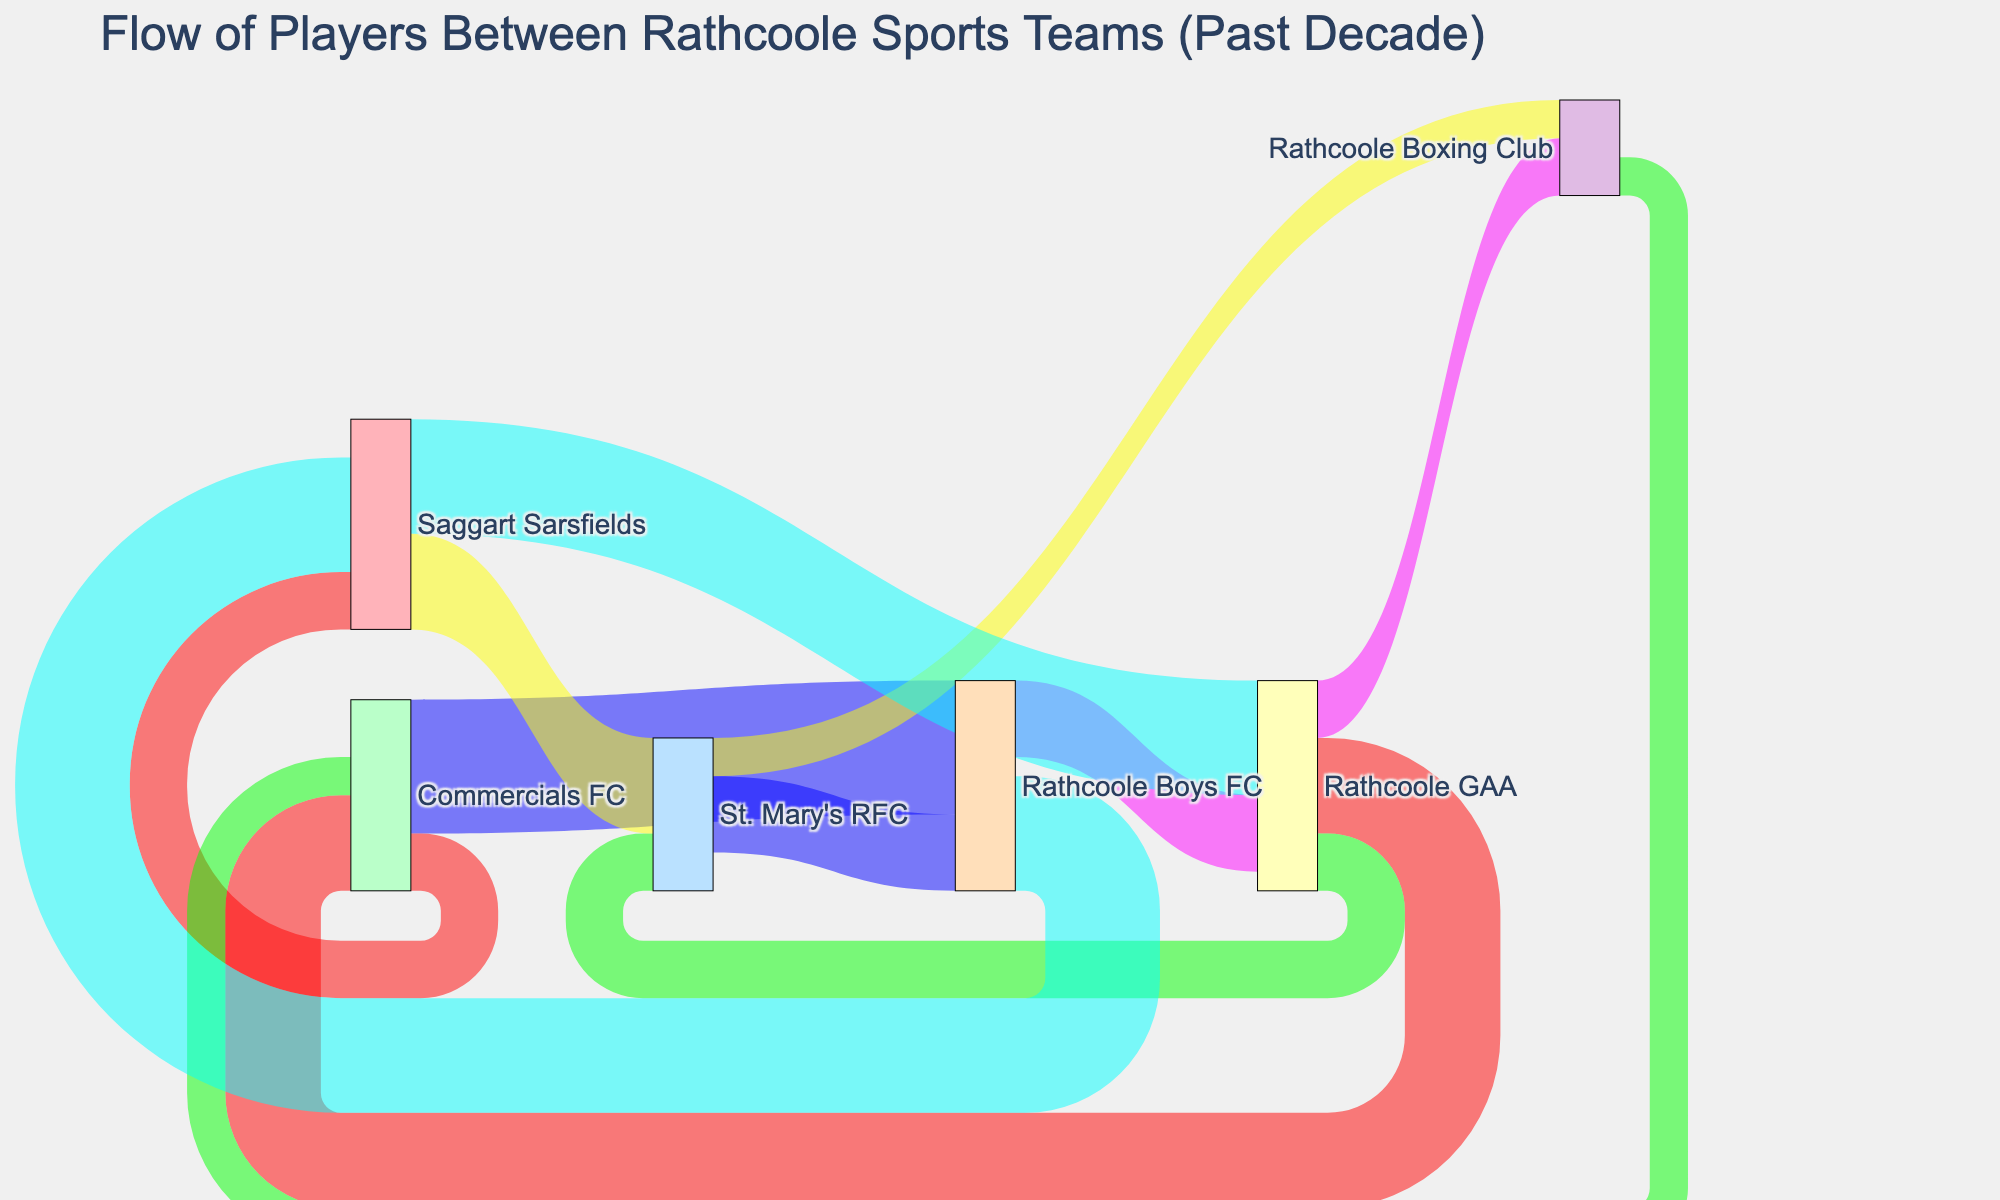How many players moved from Rathcoole GAA to other teams? Look at the links originating from Rathcoole GAA. Sum the values of the links going to Commercials FC, St. Mary's RFC, and Rathcoole Boxing Club: 5 (to Commercials FC) + 3 (to St. Mary's RFC) + 3 (to Rathcoole Boxing Club) = 11
Answer: 11 Which team received the most players from Rathcoole Boys FC? Identify the links originating from Rathcoole Boys FC and find the one with the highest value. The link values are 4 (to Rathcoole GAA) and 6 (to Saggart Sarsfields). The highest is 6 to Saggart Sarsfields
Answer: Saggart Sarsfields What is the total number of players that moved to Rathcoole GAA? Locate the links that end at Rathcoole GAA. Sum the values of these links: 4 from Rathcoole Boys FC + 6 from Saggart Sarsfields = 10
Answer: 10 Which team did Rathcoole GAA receive the most players from? Check the values of the links ending at Rathcoole GAA. The values are 4 from Rathcoole Boys FC and 6 from Saggart Sarsfields. The highest is from Saggart Sarsfields
Answer: Saggart Sarsfields What is the total number of player movements visualized in the diagram? Sum the values of all links in the diagram. The values are 5+3+7+2+4+6+3+2+4+5+3+6 = 50
Answer: 50 Which team had the highest outgoing player flow and what is the total? Add the values of all links originating from each team and identify the highest. The sums are:
- Rathcoole GAA: 5+3+3 = 11
- Commercials FC: 7+3 = 10
- St. Mary's RFC: 2+4 = 6
- Rathcoole Boys FC: 4+6 = 10
- Saggart Sarsfields: 6+5 = 11
- Rathcoole Boxing Club: 2
The highest outgoing flow is from Rathcoole GAA and Saggart Sarsfields, both with a total of 11
Answer: Rathcoole GAA and Saggart Sarsfields with 11 Between St. Mary's RFC and Commercials FC, which team received more players from Rathcoole GAA? Compare the link values from Rathcoole GAA to St. Mary's RFC and Commercials FC. The link values are 3 to St. Mary's RFC and 5 to Commercials FC
Answer: Commercials FC What is the average number of players moving between any two teams? Divide the total number of player movements by the number of links. There are 12 links and a total movement of 50 players. So, 50 / 12 ≈ 4.17
Answer: 4.17 Which teams are involved in the circular flow of players including Rathcoole Boys FC? Identify the teams in the sequence where players move from Rathcoole Boys FC and eventually return. The flow is: Rathcoole Boys FC -> Saggart Sarsfields -> St. Mary's RFC -> Rathcoole Boys FC
Answer: Rathcoole Boys FC, Saggart Sarsfields, St. Mary's RFC 